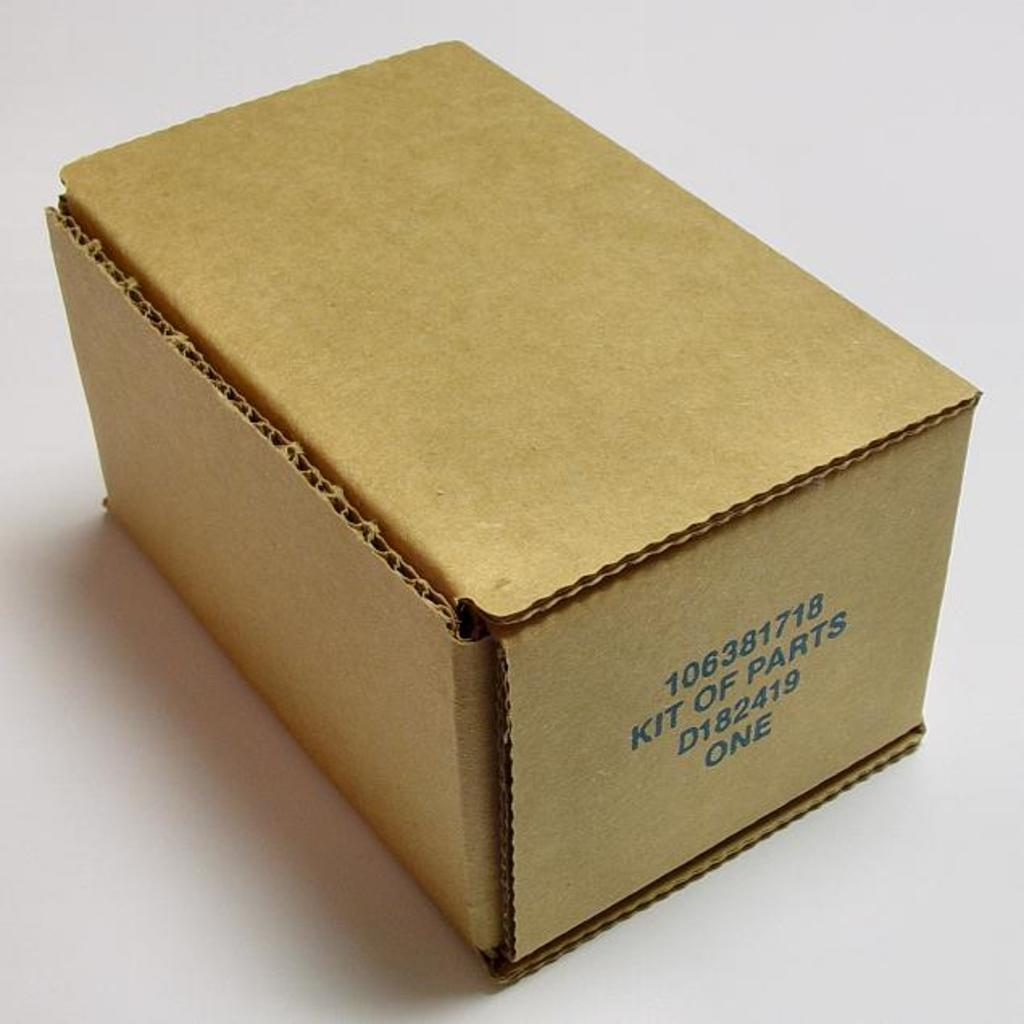<image>
Provide a brief description of the given image. Rectangle cardboard box with 106381718 kit of parts D182419 one in blue. 